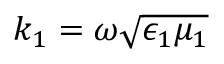<formula> <loc_0><loc_0><loc_500><loc_500>k _ { 1 } = \omega \sqrt { \epsilon _ { 1 } \mu _ { 1 } }</formula> 